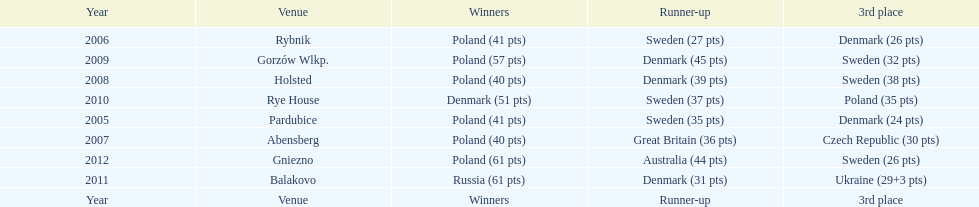Which team has the most third place wins in the speedway junior world championship between 2005 and 2012? Sweden. 